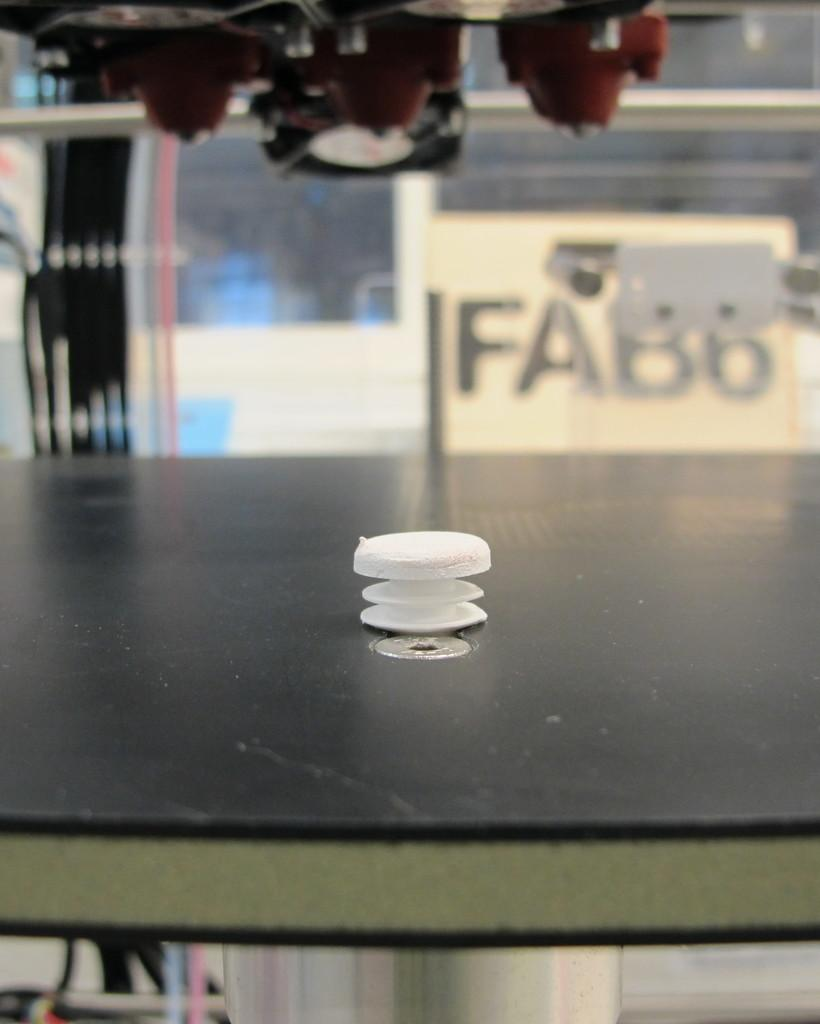What object is on the table in the image? There is a plastic screw on a table in the image. What can be seen in the background of the image? There is a glass wall in the background of the image. What type of lighting is present in the image? There are lights on the ceiling in the image. How many children are playing with the plastic screw in the image? There are no children present in the image, and the plastic screw is not being played with. 